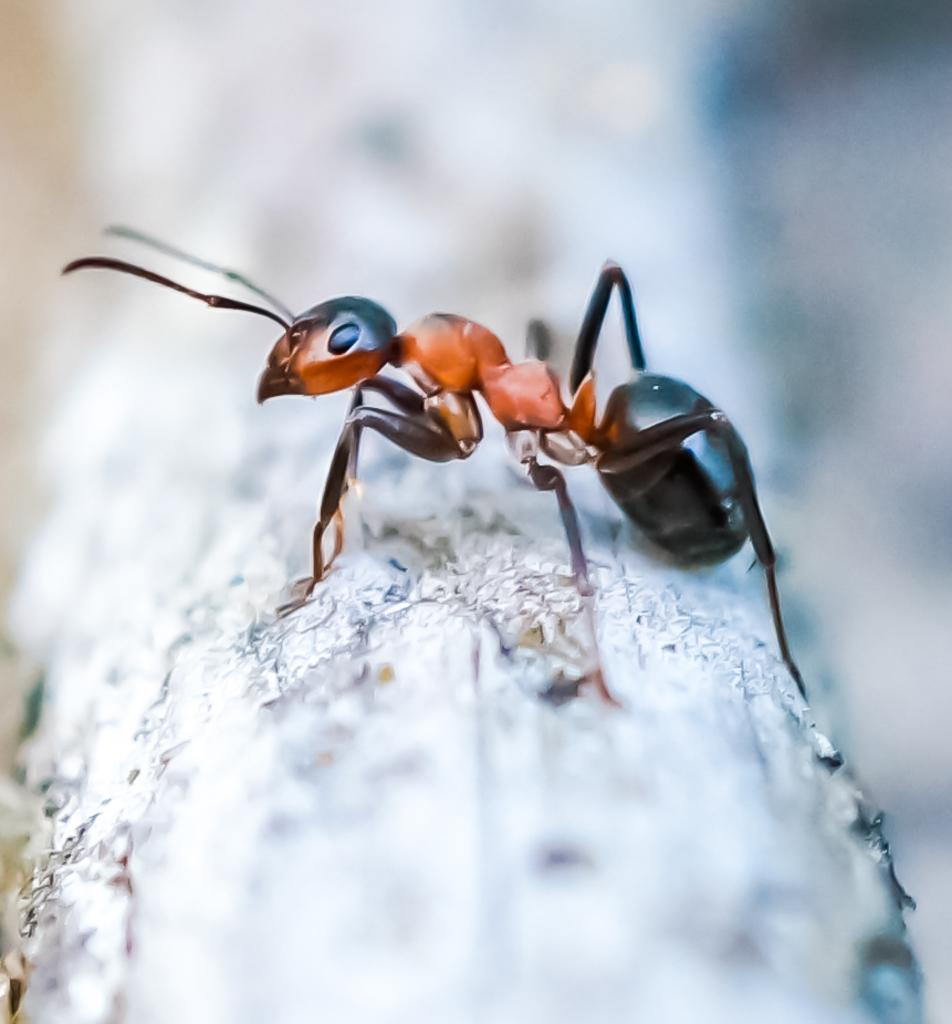What is the main subject of the image? The main subject of the image is an ant. What body parts does the ant have? The ant has legs. On what type of surface is the ant located? The ant is on a wooden surface. How would you describe the background of the image? The background of the image is blurred. What type of bird can be seen coughing in the image? There is no bird present in the image, and therefore no such activity can be observed. 